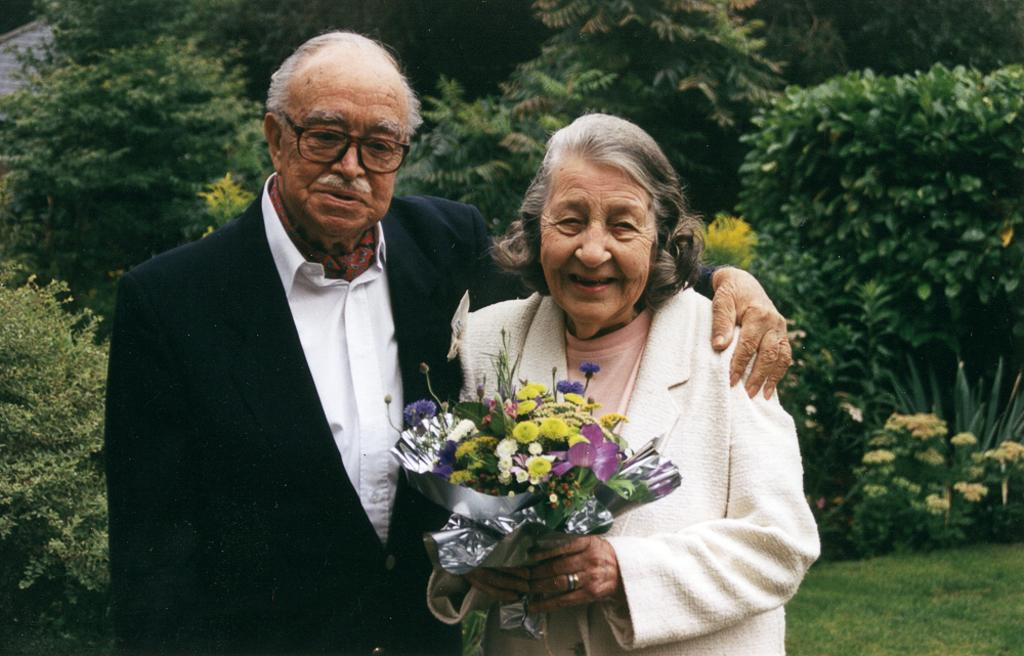Who are the two people in the center of the image? There is a man and a woman in the center of the image. What are the man and woman holding in the image? The man and woman are holding a bouquet. What can be seen in the background of the image? There are trees, plants, and flowers in the background of the image. What type of waves can be seen in the image? There are no waves present in the image; it features a man and a woman holding a bouquet with trees, plants, and flowers in the background. 